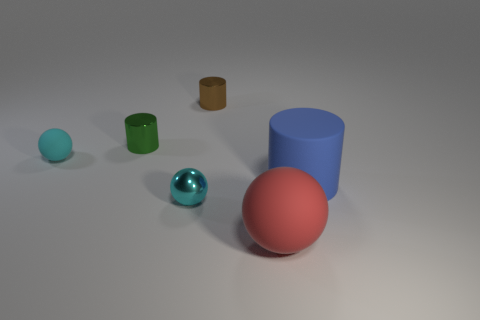How many other objects are the same size as the blue thing?
Provide a succinct answer. 1. How many blocks are either green shiny things or small brown things?
Provide a short and direct response. 0. Is there anything else that is the same material as the brown object?
Offer a very short reply. Yes. What is the tiny ball on the right side of the small ball behind the small object in front of the big blue rubber cylinder made of?
Provide a short and direct response. Metal. There is another ball that is the same color as the tiny matte ball; what is it made of?
Offer a very short reply. Metal. How many cylinders have the same material as the small brown thing?
Your response must be concise. 1. There is a matte sphere that is left of the red sphere; does it have the same size as the brown object?
Make the answer very short. Yes. There is a cylinder that is the same material as the tiny green thing; what color is it?
Give a very brief answer. Brown. Are there any other things that have the same size as the red object?
Keep it short and to the point. Yes. There is a large blue cylinder; how many metallic objects are in front of it?
Provide a short and direct response. 1. 